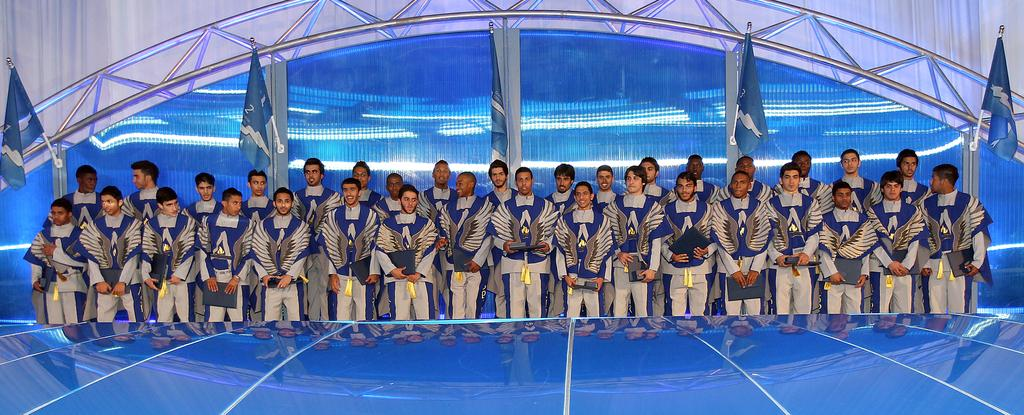What is the main subject of the image? The main subject of the image is a group of people. What are the people in the image doing? The people are standing in the image. What are the people holding in their hands? The people are holding objects in their hands. What can be seen in the background of the image? There are flags in the background of the image. What type of lead is being used by the people in the image? There is no lead present in the image; the people are holding objects, but there is no indication of what those objects are. 